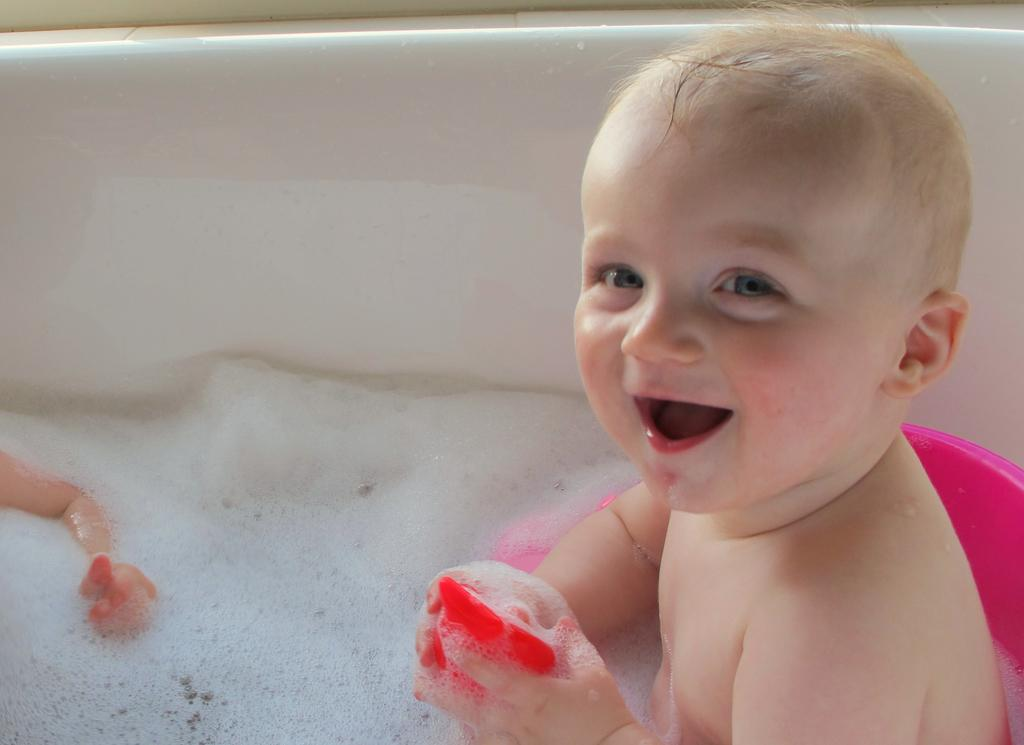What can be seen in the image? There are kids in the image. Where are the kids located? The kids are in a bathtub. What is the kid on the right side of the image holding? One of the kids is holding an object. What type of container is present in the image? There is a tub in the image. What can be observed in the water in the image? There is foam visible in the image. What is the purpose of the hall in the image? There is no hall present in the image; it features kids in a bathtub. 